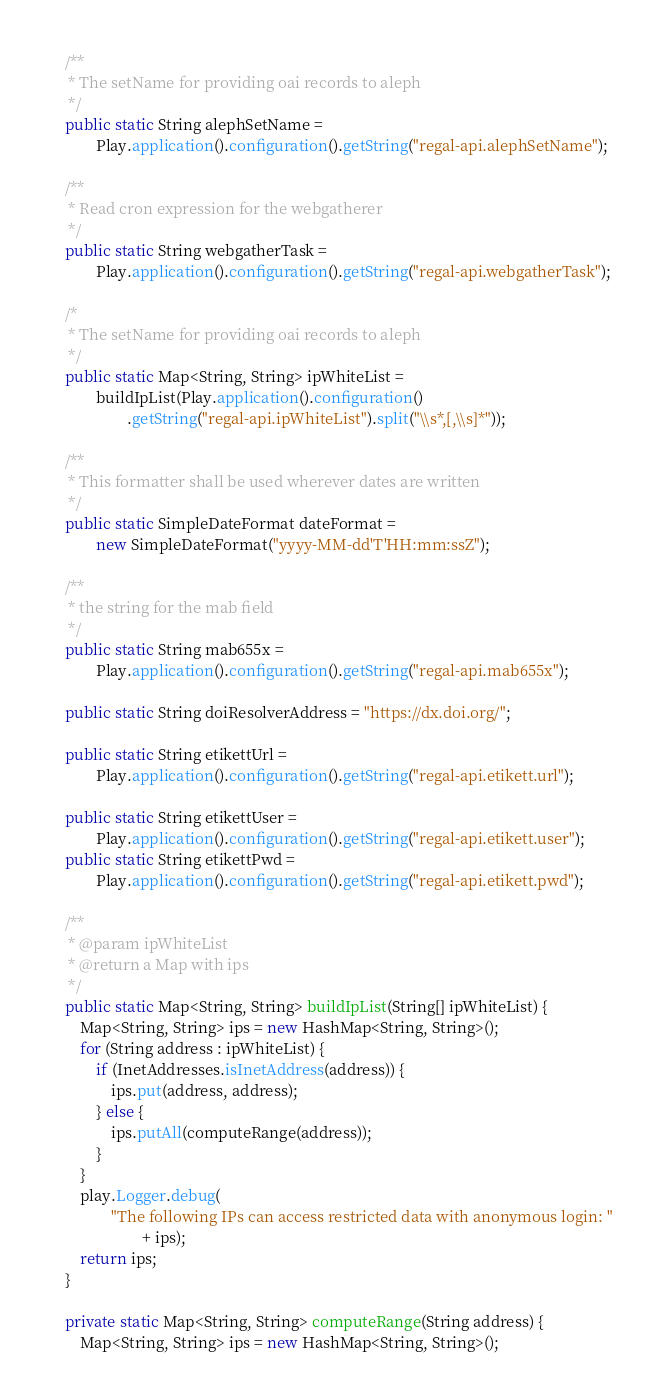<code> <loc_0><loc_0><loc_500><loc_500><_Java_>
	/**
	 * The setName for providing oai records to aleph
	 */
	public static String alephSetName =
			Play.application().configuration().getString("regal-api.alephSetName");

	/**
	 * Read cron expression for the webgatherer
	 */
	public static String webgatherTask =
			Play.application().configuration().getString("regal-api.webgatherTask");

	/*
	 * The setName for providing oai records to aleph
	 */
	public static Map<String, String> ipWhiteList =
			buildIpList(Play.application().configuration()
					.getString("regal-api.ipWhiteList").split("\\s*,[,\\s]*"));

	/**
	 * This formatter shall be used wherever dates are written
	 */
	public static SimpleDateFormat dateFormat =
			new SimpleDateFormat("yyyy-MM-dd'T'HH:mm:ssZ");

	/**
	 * the string for the mab field
	 */
	public static String mab655x =
			Play.application().configuration().getString("regal-api.mab655x");

	public static String doiResolverAddress = "https://dx.doi.org/";

	public static String etikettUrl =
			Play.application().configuration().getString("regal-api.etikett.url");

	public static String etikettUser =
			Play.application().configuration().getString("regal-api.etikett.user");
	public static String etikettPwd =
			Play.application().configuration().getString("regal-api.etikett.pwd");

	/**
	 * @param ipWhiteList
	 * @return a Map with ips
	 */
	public static Map<String, String> buildIpList(String[] ipWhiteList) {
		Map<String, String> ips = new HashMap<String, String>();
		for (String address : ipWhiteList) {
			if (InetAddresses.isInetAddress(address)) {
				ips.put(address, address);
			} else {
				ips.putAll(computeRange(address));
			}
		}
		play.Logger.debug(
				"The following IPs can access restricted data with anonymous login: "
						+ ips);
		return ips;
	}

	private static Map<String, String> computeRange(String address) {
		Map<String, String> ips = new HashMap<String, String>();</code> 